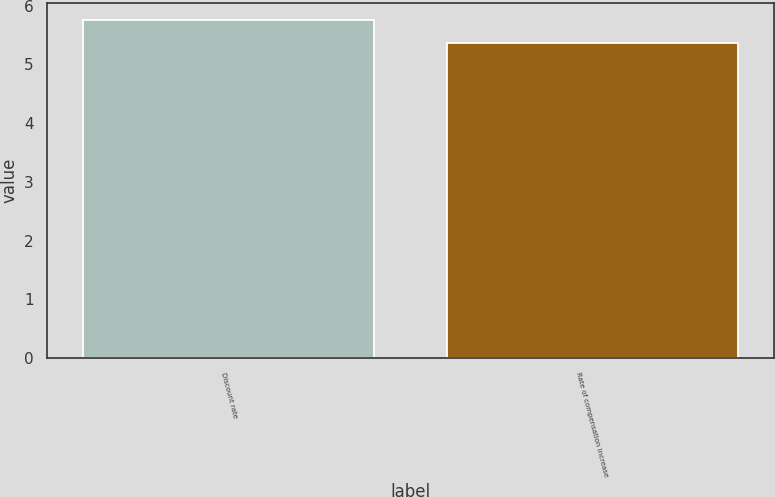<chart> <loc_0><loc_0><loc_500><loc_500><bar_chart><fcel>Discount rate<fcel>Rate of compensation increase<nl><fcel>5.75<fcel>5.37<nl></chart> 